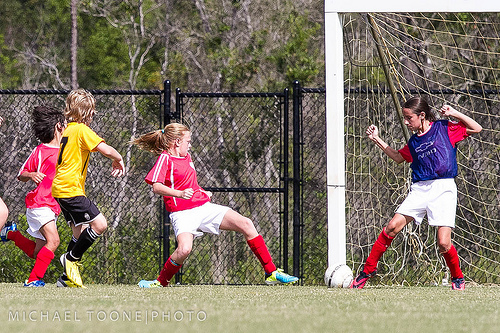<image>
Is there a fence in front of the girl? No. The fence is not in front of the girl. The spatial positioning shows a different relationship between these objects. 